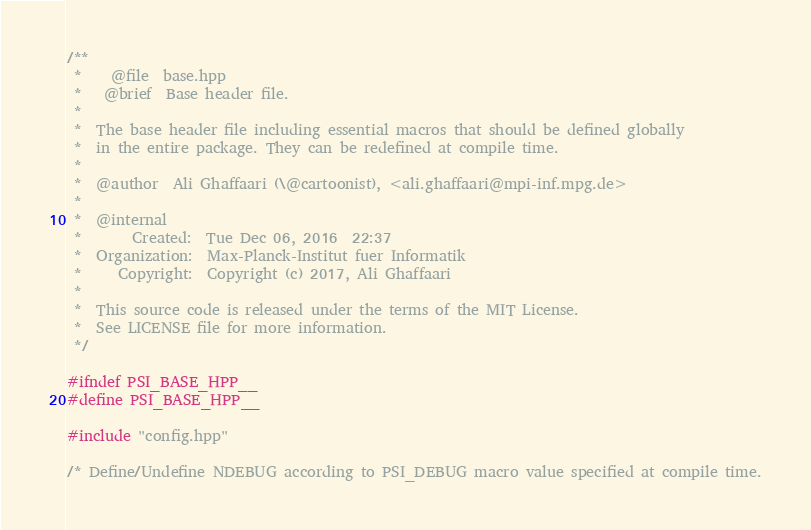Convert code to text. <code><loc_0><loc_0><loc_500><loc_500><_C++_>/**
 *    @file  base.hpp
 *   @brief  Base header file.
 *
 *  The base header file including essential macros that should be defined globally
 *  in the entire package. They can be redefined at compile time.
 *
 *  @author  Ali Ghaffaari (\@cartoonist), <ali.ghaffaari@mpi-inf.mpg.de>
 *
 *  @internal
 *       Created:  Tue Dec 06, 2016  22:37
 *  Organization:  Max-Planck-Institut fuer Informatik
 *     Copyright:  Copyright (c) 2017, Ali Ghaffaari
 *
 *  This source code is released under the terms of the MIT License.
 *  See LICENSE file for more information.
 */

#ifndef PSI_BASE_HPP__
#define PSI_BASE_HPP__

#include "config.hpp"

/* Define/Undefine NDEBUG according to PSI_DEBUG macro value specified at compile time.</code> 